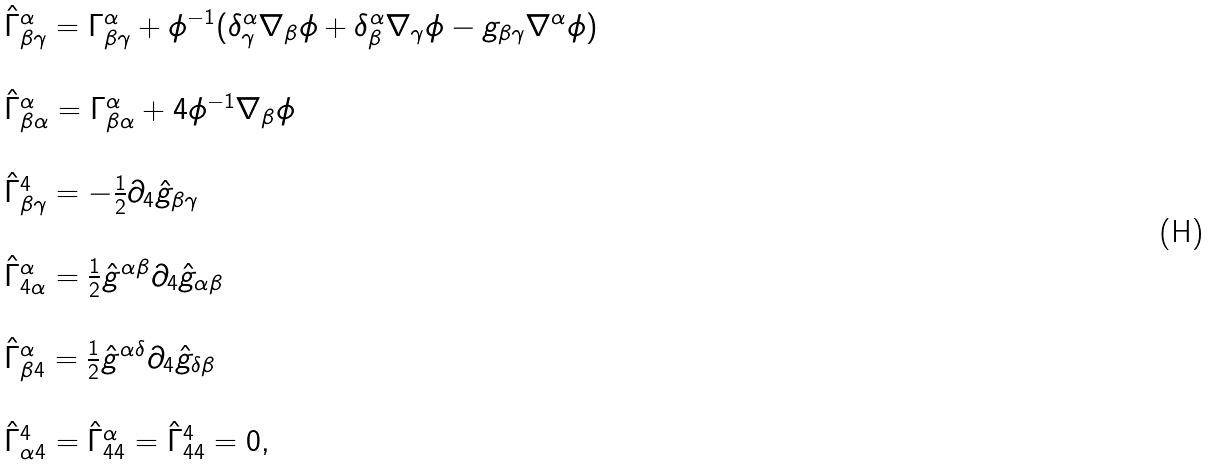Convert formula to latex. <formula><loc_0><loc_0><loc_500><loc_500>\begin{array} { l l } \hat { \Gamma } ^ { \alpha } _ { \beta \gamma } = \Gamma ^ { \alpha } _ { \beta \gamma } + \phi ^ { - 1 } ( \delta ^ { \alpha } _ { \gamma } \nabla _ { \beta } \phi + \delta ^ { \alpha } _ { \beta } \nabla _ { \gamma } \phi - g _ { \beta \gamma } \nabla ^ { \alpha } \phi ) \\ \\ \hat { \Gamma } ^ { \alpha } _ { \beta \alpha } = \Gamma ^ { \alpha } _ { \beta \alpha } + 4 \phi ^ { - 1 } \nabla _ { \beta } \phi \\ \\ \hat { \Gamma } ^ { 4 } _ { \beta \gamma } = - \frac { 1 } { 2 } \partial _ { 4 } \hat { g } _ { \beta \gamma } \\ \\ \hat { \Gamma } ^ { \alpha } _ { 4 \alpha } = \frac { 1 } { 2 } \hat { g } ^ { \alpha \beta } \partial _ { 4 } \hat { g } _ { \alpha \beta } \\ \\ \hat { \Gamma } ^ { \alpha } _ { \beta 4 } = \frac { 1 } { 2 } \hat { g } ^ { \alpha \delta } \partial _ { 4 } \hat { g } _ { \delta \beta } \\ \\ \hat { \Gamma } ^ { 4 } _ { \alpha 4 } = \hat { \Gamma } ^ { \alpha } _ { 4 4 } = \hat { \Gamma } ^ { 4 } _ { 4 4 } = 0 , \end{array}</formula> 